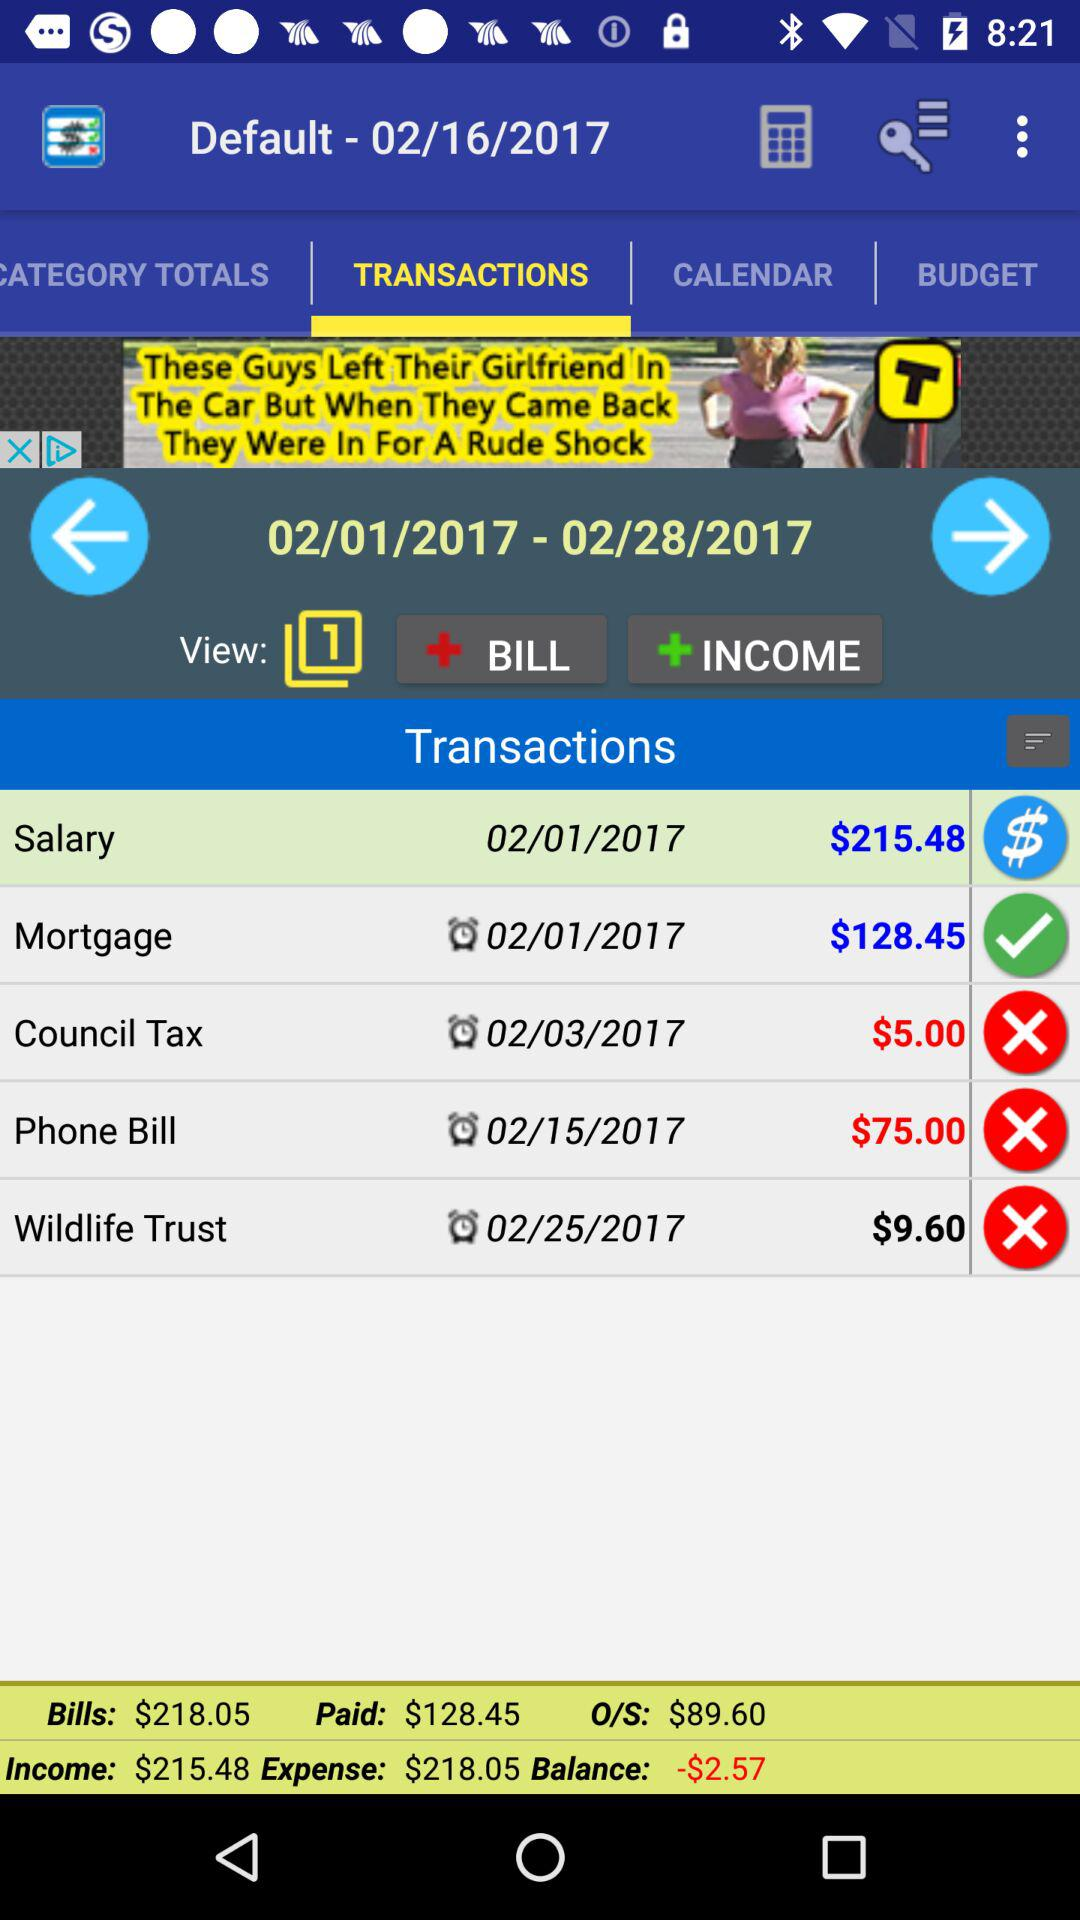How many views are shown there? There is 1 shown view. 